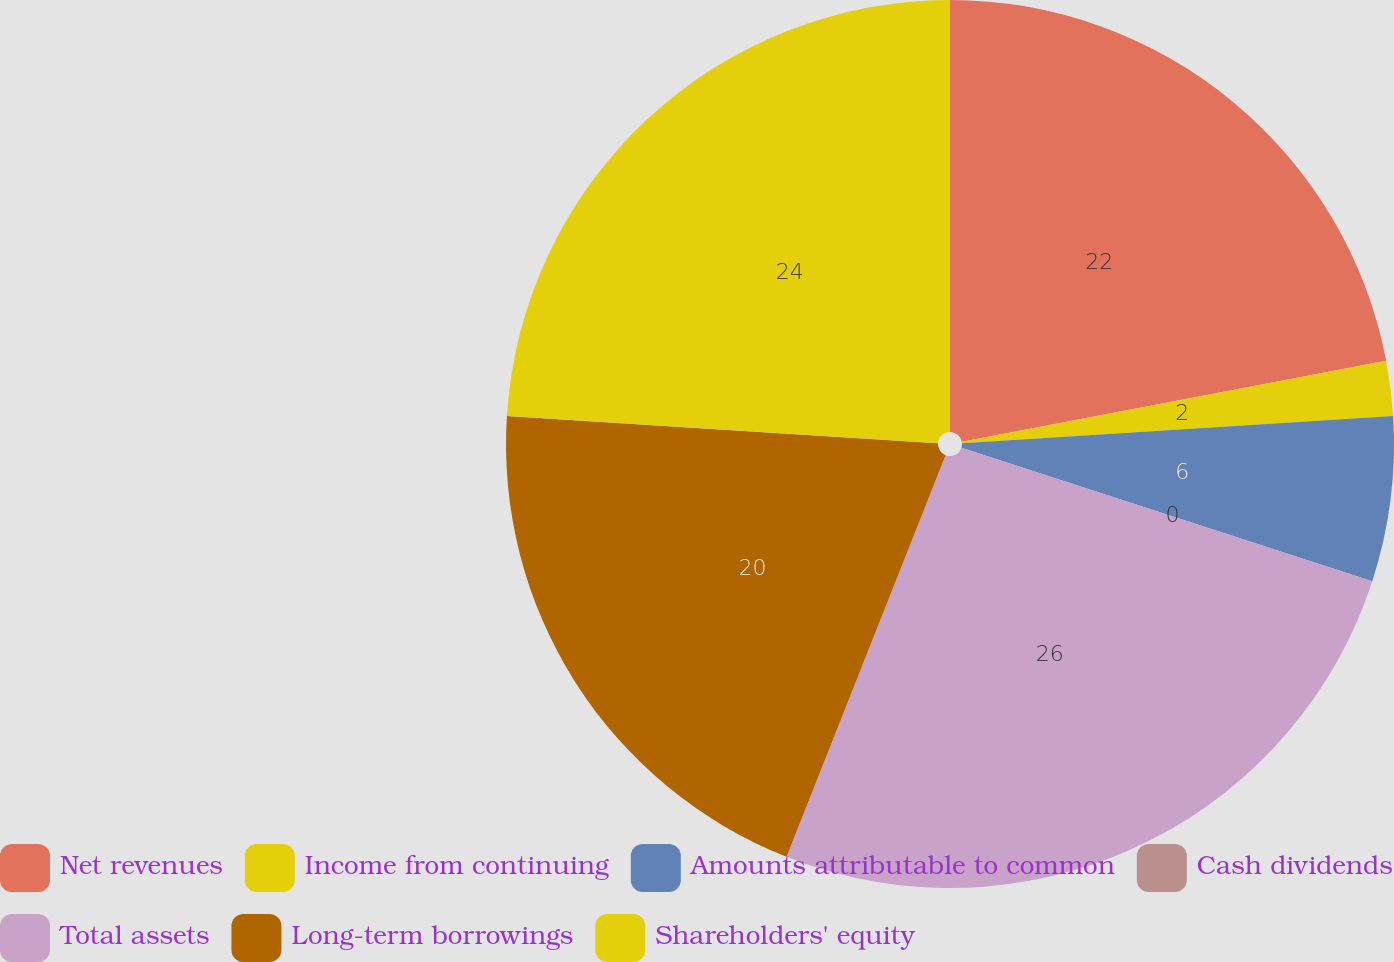Convert chart. <chart><loc_0><loc_0><loc_500><loc_500><pie_chart><fcel>Net revenues<fcel>Income from continuing<fcel>Amounts attributable to common<fcel>Cash dividends<fcel>Total assets<fcel>Long-term borrowings<fcel>Shareholders' equity<nl><fcel>22.0%<fcel>2.0%<fcel>6.0%<fcel>0.0%<fcel>26.0%<fcel>20.0%<fcel>24.0%<nl></chart> 